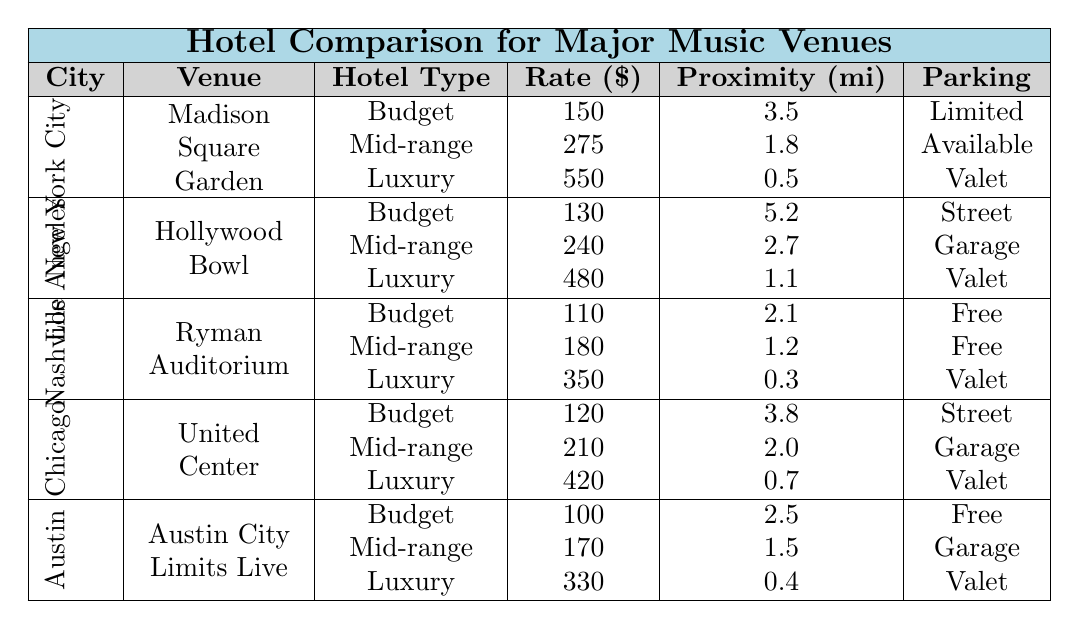What is the hotel rate for a Budget option in Nashville? The table shows that in Nashville, the rate for a Budget hotel is $110.
Answer: $110 Which city has the lowest hotel rate for Mid-range accommodation? To find the lowest Mid-range rate, compare the rates for Mid-range hotels in each city: NYC - $275, LA - $240, Nashville - $180, Chicago - $210, Austin - $170. The lowest is in Austin at $170.
Answer: $170 What is the Proximity to Venue for Luxury hotels in Chicago? According to the table, the proximity to the venue for Luxury hotels in Chicago is 0.7 miles.
Answer: 0.7 miles Is parking available for all hotel types in Nashville? In Nashville, the table indicates that Budget and Mid-range hotels have Free parking, while Luxury hotels offer Valet parking, meaning parking is available for all types.
Answer: Yes Which city offers the most affordable Luxury hotel option? The Luxury hotel rates are $550 in NYC, $480 in LA, $350 in Nashville, $420 in Chicago, and $330 in Austin. Austin has the most affordable Luxury hotel at $330.
Answer: $330 What is the difference between the Budget and Luxury hotel rates in Los Angeles? The Budget rate in Los Angeles is $130 and the Luxury rate is $480. The difference is calculated as $480 - $130 = $350.
Answer: $350 Are there any Free parking options available in Austin? The table shows that both Budget and Mid-range hotels in Austin offer Free parking, confirming the availability of Free parking options.
Answer: Yes What is the average hotel rate for all hotel types in New York City? The rates in NYC are Budget: $150, Mid-range: $275, Luxury: $550. To find the average, sum these rates ($150 + $275 + $550 = $975) and divide by the number of hotels (3). The average is $975 / 3 = $325.
Answer: $325 Which city has the highest proximity to venue for Budget hotels? Checking the Budget hotel proximities: NYC - 3.5, LA - 5.2, Nashville - 2.1, Chicago - 3.8, Austin - 2.5. Los Angeles has the highest proximity at 5.2 miles.
Answer: 5.2 miles What type of parking is available for Luxury hotels in New York City? According to the table, Luxury hotels in New York City offer Valet parking.
Answer: Valet 